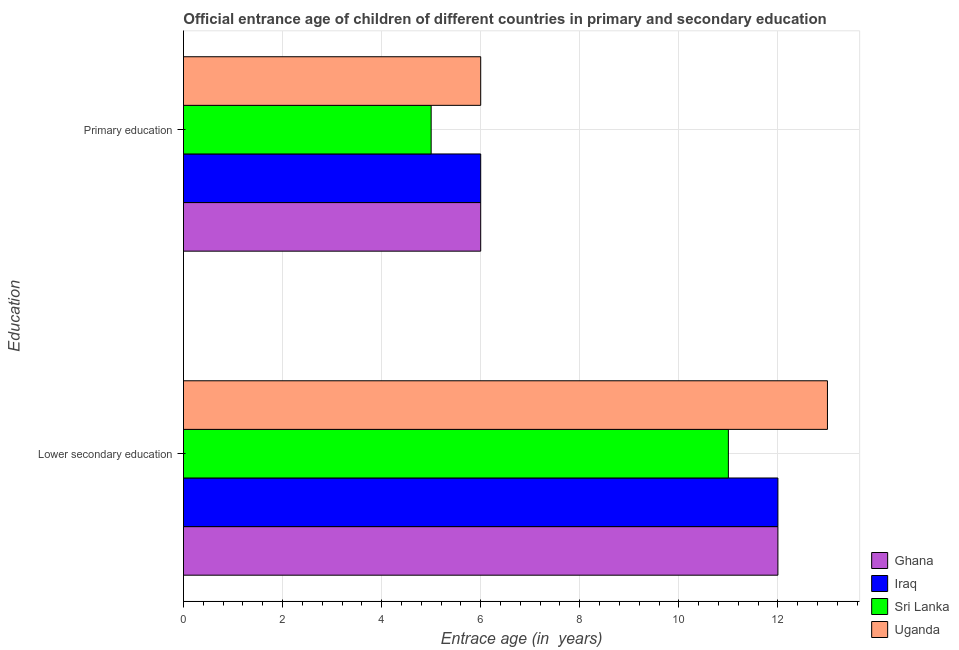How many different coloured bars are there?
Give a very brief answer. 4. How many groups of bars are there?
Offer a terse response. 2. Are the number of bars per tick equal to the number of legend labels?
Provide a succinct answer. Yes. How many bars are there on the 1st tick from the bottom?
Provide a short and direct response. 4. Across all countries, what is the maximum entrance age of chiildren in primary education?
Offer a very short reply. 6. Across all countries, what is the minimum entrance age of chiildren in primary education?
Offer a very short reply. 5. In which country was the entrance age of children in lower secondary education maximum?
Provide a short and direct response. Uganda. In which country was the entrance age of chiildren in primary education minimum?
Give a very brief answer. Sri Lanka. What is the total entrance age of chiildren in primary education in the graph?
Make the answer very short. 23. What is the difference between the entrance age of children in lower secondary education in Ghana and that in Sri Lanka?
Provide a short and direct response. 1. What is the difference between the entrance age of children in lower secondary education in Iraq and the entrance age of chiildren in primary education in Sri Lanka?
Provide a succinct answer. 7. What is the difference between the entrance age of children in lower secondary education and entrance age of chiildren in primary education in Uganda?
Your answer should be compact. 7. Is the entrance age of children in lower secondary education in Uganda less than that in Iraq?
Make the answer very short. No. What does the 3rd bar from the top in Primary education represents?
Give a very brief answer. Iraq. How many bars are there?
Your response must be concise. 8. Are all the bars in the graph horizontal?
Give a very brief answer. Yes. How many countries are there in the graph?
Offer a very short reply. 4. What is the difference between two consecutive major ticks on the X-axis?
Offer a very short reply. 2. Does the graph contain any zero values?
Your response must be concise. No. What is the title of the graph?
Keep it short and to the point. Official entrance age of children of different countries in primary and secondary education. What is the label or title of the X-axis?
Offer a very short reply. Entrace age (in  years). What is the label or title of the Y-axis?
Provide a succinct answer. Education. What is the Entrace age (in  years) in Sri Lanka in Primary education?
Give a very brief answer. 5. Across all Education, what is the maximum Entrace age (in  years) in Sri Lanka?
Offer a very short reply. 11. Across all Education, what is the minimum Entrace age (in  years) in Uganda?
Keep it short and to the point. 6. What is the total Entrace age (in  years) of Ghana in the graph?
Provide a short and direct response. 18. What is the total Entrace age (in  years) of Iraq in the graph?
Your answer should be very brief. 18. What is the total Entrace age (in  years) in Sri Lanka in the graph?
Your response must be concise. 16. What is the difference between the Entrace age (in  years) of Uganda in Lower secondary education and that in Primary education?
Give a very brief answer. 7. What is the difference between the Entrace age (in  years) of Ghana in Lower secondary education and the Entrace age (in  years) of Iraq in Primary education?
Your answer should be compact. 6. What is the difference between the Entrace age (in  years) of Ghana in Lower secondary education and the Entrace age (in  years) of Uganda in Primary education?
Ensure brevity in your answer.  6. What is the difference between the Entrace age (in  years) of Iraq in Lower secondary education and the Entrace age (in  years) of Uganda in Primary education?
Offer a very short reply. 6. What is the difference between the Entrace age (in  years) of Sri Lanka in Lower secondary education and the Entrace age (in  years) of Uganda in Primary education?
Provide a short and direct response. 5. What is the average Entrace age (in  years) in Ghana per Education?
Offer a terse response. 9. What is the difference between the Entrace age (in  years) in Ghana and Entrace age (in  years) in Uganda in Lower secondary education?
Keep it short and to the point. -1. What is the difference between the Entrace age (in  years) in Iraq and Entrace age (in  years) in Uganda in Lower secondary education?
Make the answer very short. -1. What is the difference between the Entrace age (in  years) in Ghana and Entrace age (in  years) in Sri Lanka in Primary education?
Your response must be concise. 1. What is the ratio of the Entrace age (in  years) in Iraq in Lower secondary education to that in Primary education?
Your response must be concise. 2. What is the ratio of the Entrace age (in  years) of Sri Lanka in Lower secondary education to that in Primary education?
Make the answer very short. 2.2. What is the ratio of the Entrace age (in  years) of Uganda in Lower secondary education to that in Primary education?
Provide a succinct answer. 2.17. What is the difference between the highest and the second highest Entrace age (in  years) of Iraq?
Keep it short and to the point. 6. What is the difference between the highest and the second highest Entrace age (in  years) of Sri Lanka?
Give a very brief answer. 6. What is the difference between the highest and the second highest Entrace age (in  years) in Uganda?
Give a very brief answer. 7. What is the difference between the highest and the lowest Entrace age (in  years) in Uganda?
Make the answer very short. 7. 